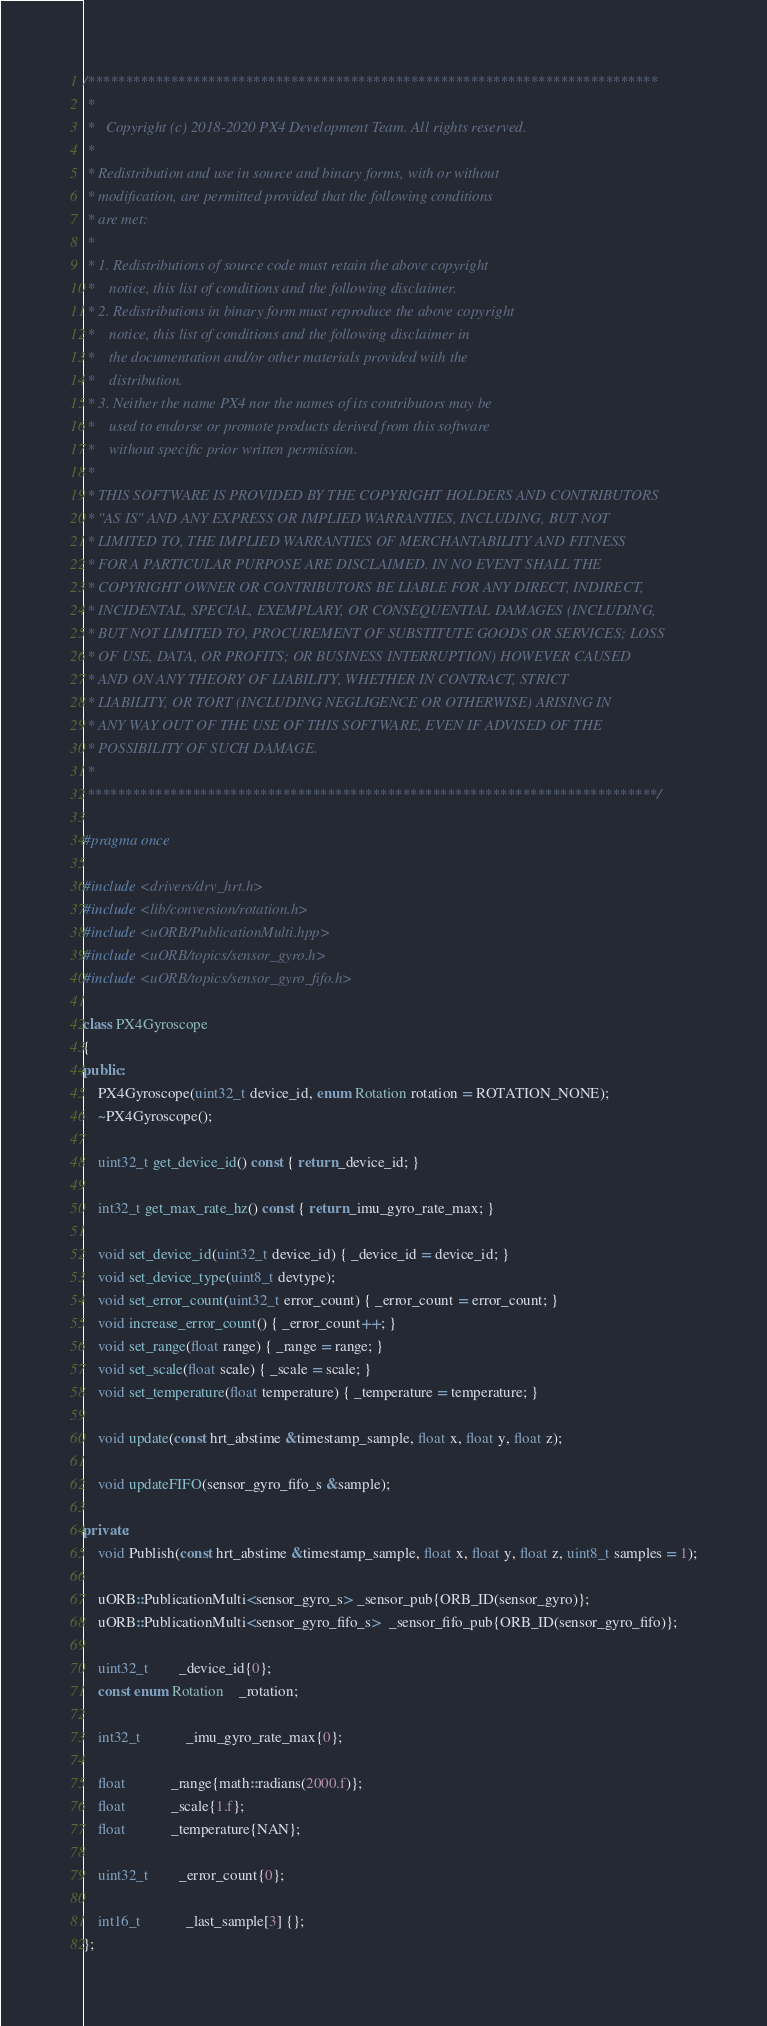<code> <loc_0><loc_0><loc_500><loc_500><_C++_>/****************************************************************************
 *
 *   Copyright (c) 2018-2020 PX4 Development Team. All rights reserved.
 *
 * Redistribution and use in source and binary forms, with or without
 * modification, are permitted provided that the following conditions
 * are met:
 *
 * 1. Redistributions of source code must retain the above copyright
 *    notice, this list of conditions and the following disclaimer.
 * 2. Redistributions in binary form must reproduce the above copyright
 *    notice, this list of conditions and the following disclaimer in
 *    the documentation and/or other materials provided with the
 *    distribution.
 * 3. Neither the name PX4 nor the names of its contributors may be
 *    used to endorse or promote products derived from this software
 *    without specific prior written permission.
 *
 * THIS SOFTWARE IS PROVIDED BY THE COPYRIGHT HOLDERS AND CONTRIBUTORS
 * "AS IS" AND ANY EXPRESS OR IMPLIED WARRANTIES, INCLUDING, BUT NOT
 * LIMITED TO, THE IMPLIED WARRANTIES OF MERCHANTABILITY AND FITNESS
 * FOR A PARTICULAR PURPOSE ARE DISCLAIMED. IN NO EVENT SHALL THE
 * COPYRIGHT OWNER OR CONTRIBUTORS BE LIABLE FOR ANY DIRECT, INDIRECT,
 * INCIDENTAL, SPECIAL, EXEMPLARY, OR CONSEQUENTIAL DAMAGES (INCLUDING,
 * BUT NOT LIMITED TO, PROCUREMENT OF SUBSTITUTE GOODS OR SERVICES; LOSS
 * OF USE, DATA, OR PROFITS; OR BUSINESS INTERRUPTION) HOWEVER CAUSED
 * AND ON ANY THEORY OF LIABILITY, WHETHER IN CONTRACT, STRICT
 * LIABILITY, OR TORT (INCLUDING NEGLIGENCE OR OTHERWISE) ARISING IN
 * ANY WAY OUT OF THE USE OF THIS SOFTWARE, EVEN IF ADVISED OF THE
 * POSSIBILITY OF SUCH DAMAGE.
 *
 ****************************************************************************/

#pragma once

#include <drivers/drv_hrt.h>
#include <lib/conversion/rotation.h>
#include <uORB/PublicationMulti.hpp>
#include <uORB/topics/sensor_gyro.h>
#include <uORB/topics/sensor_gyro_fifo.h>

class PX4Gyroscope
{
public:
	PX4Gyroscope(uint32_t device_id, enum Rotation rotation = ROTATION_NONE);
	~PX4Gyroscope();

	uint32_t get_device_id() const { return _device_id; }

	int32_t get_max_rate_hz() const { return _imu_gyro_rate_max; }

	void set_device_id(uint32_t device_id) { _device_id = device_id; }
	void set_device_type(uint8_t devtype);
	void set_error_count(uint32_t error_count) { _error_count = error_count; }
	void increase_error_count() { _error_count++; }
	void set_range(float range) { _range = range; }
	void set_scale(float scale) { _scale = scale; }
	void set_temperature(float temperature) { _temperature = temperature; }

	void update(const hrt_abstime &timestamp_sample, float x, float y, float z);

	void updateFIFO(sensor_gyro_fifo_s &sample);

private:
	void Publish(const hrt_abstime &timestamp_sample, float x, float y, float z, uint8_t samples = 1);

	uORB::PublicationMulti<sensor_gyro_s> _sensor_pub{ORB_ID(sensor_gyro)};
	uORB::PublicationMulti<sensor_gyro_fifo_s>  _sensor_fifo_pub{ORB_ID(sensor_gyro_fifo)};

	uint32_t		_device_id{0};
	const enum Rotation	_rotation;

	int32_t			_imu_gyro_rate_max{0};

	float			_range{math::radians(2000.f)};
	float			_scale{1.f};
	float			_temperature{NAN};

	uint32_t		_error_count{0};

	int16_t			_last_sample[3] {};
};
</code> 